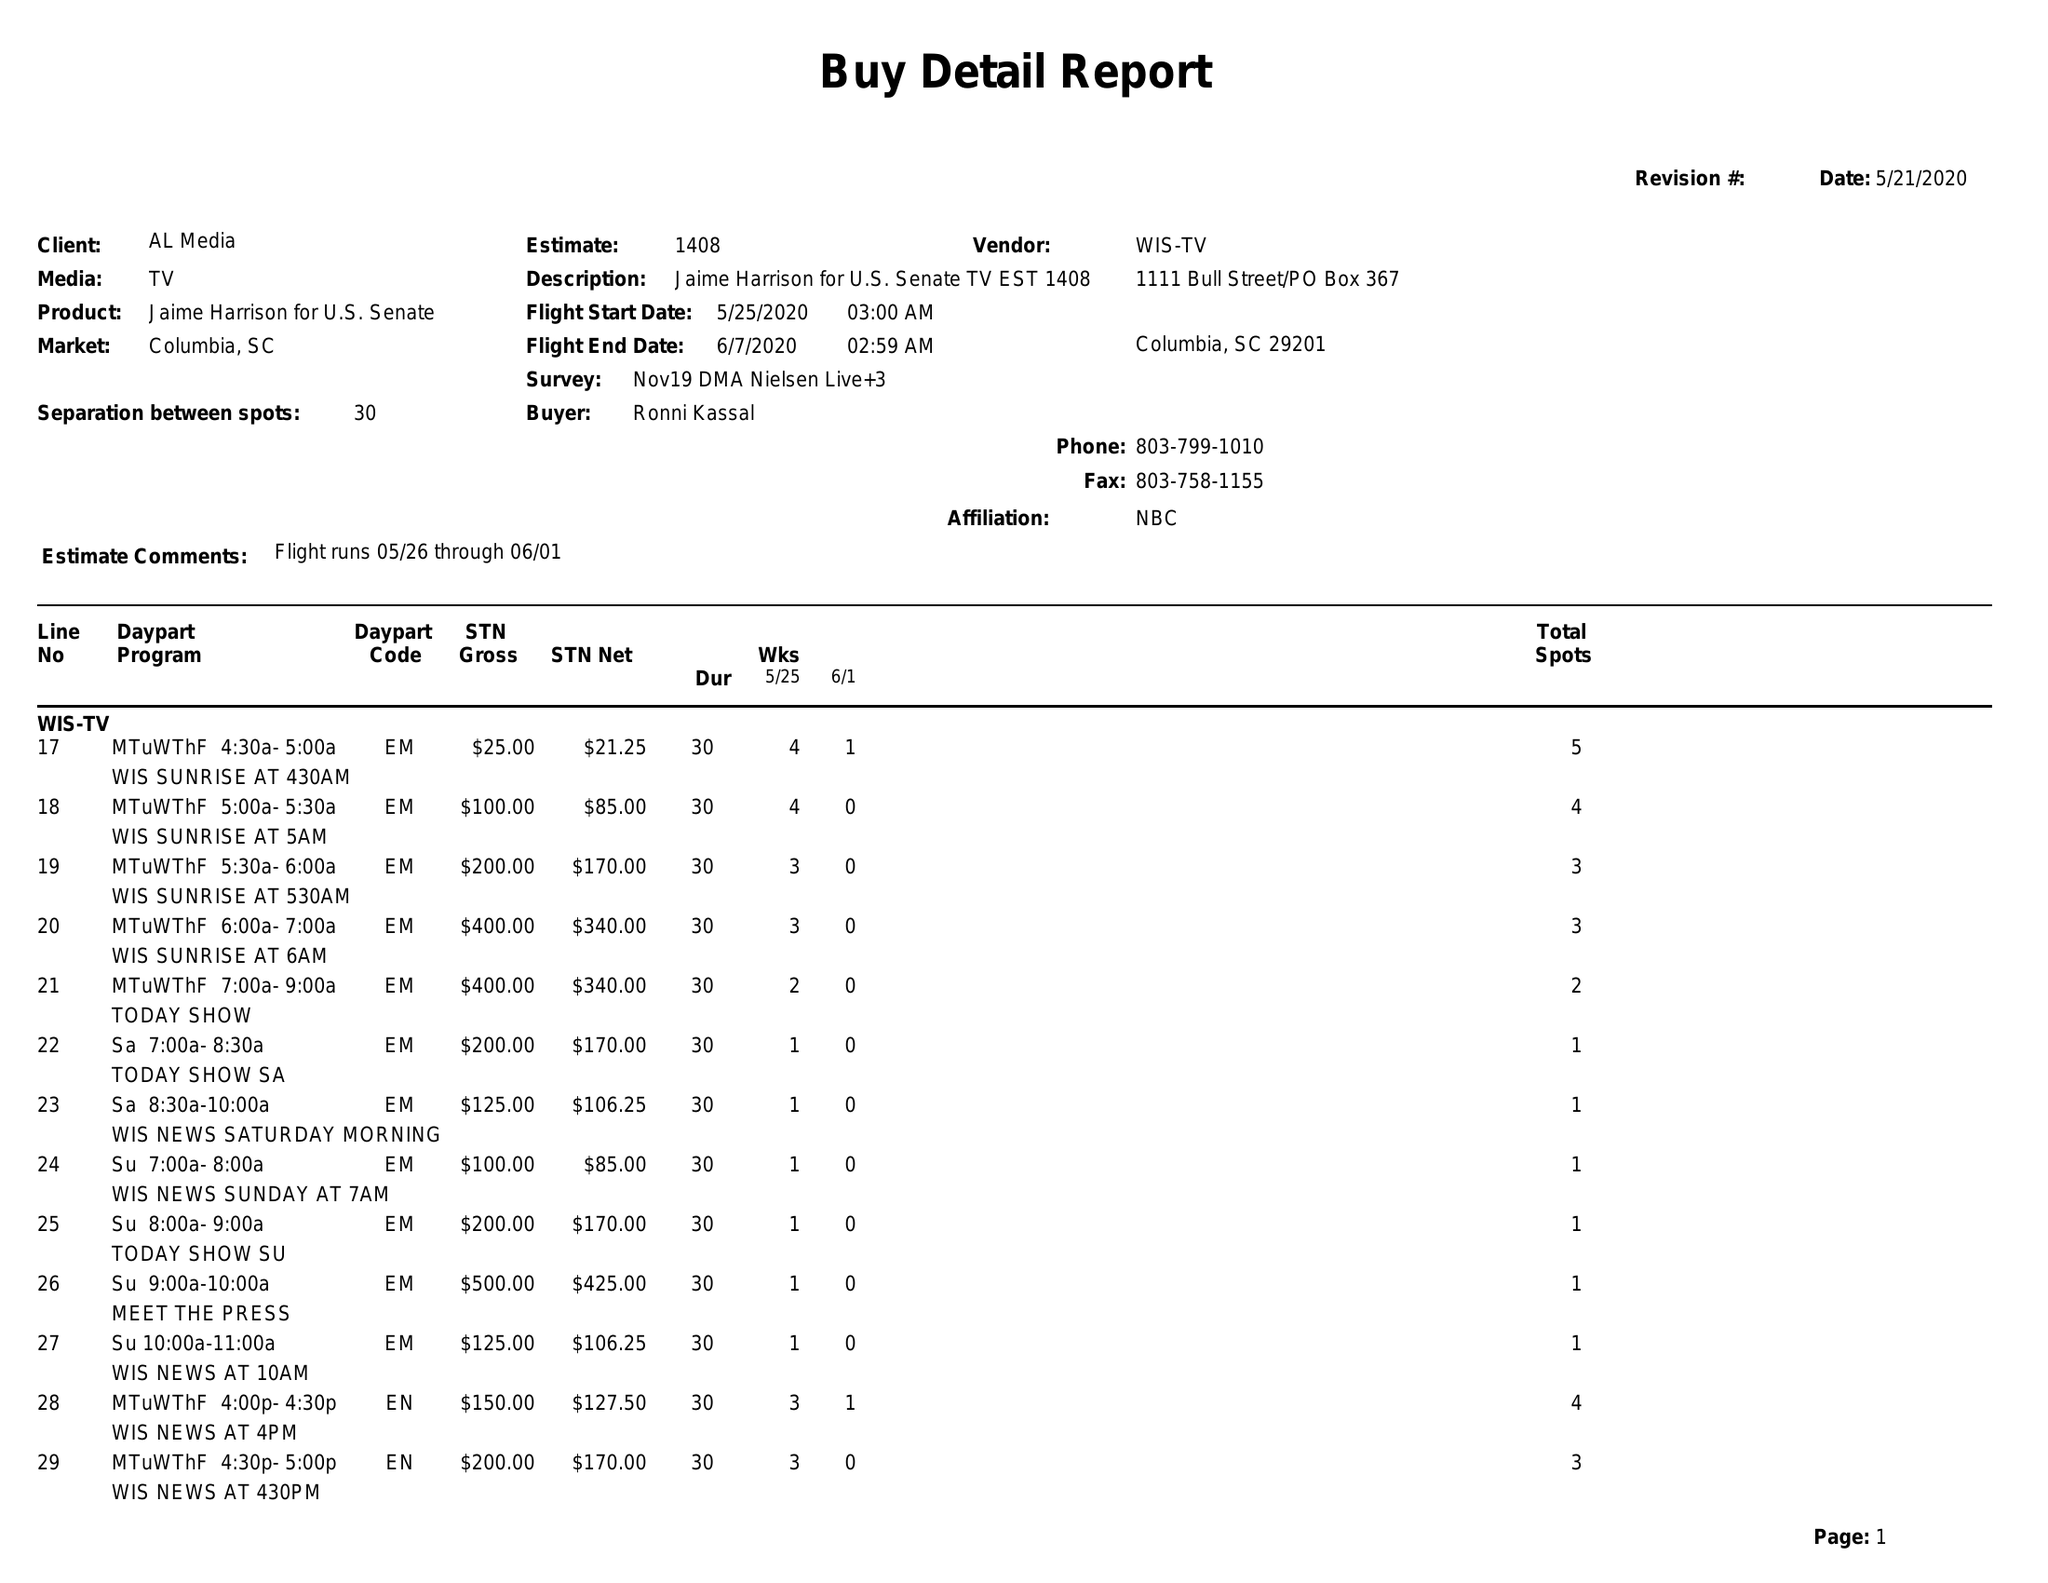What is the value for the contract_num?
Answer the question using a single word or phrase. 1408 